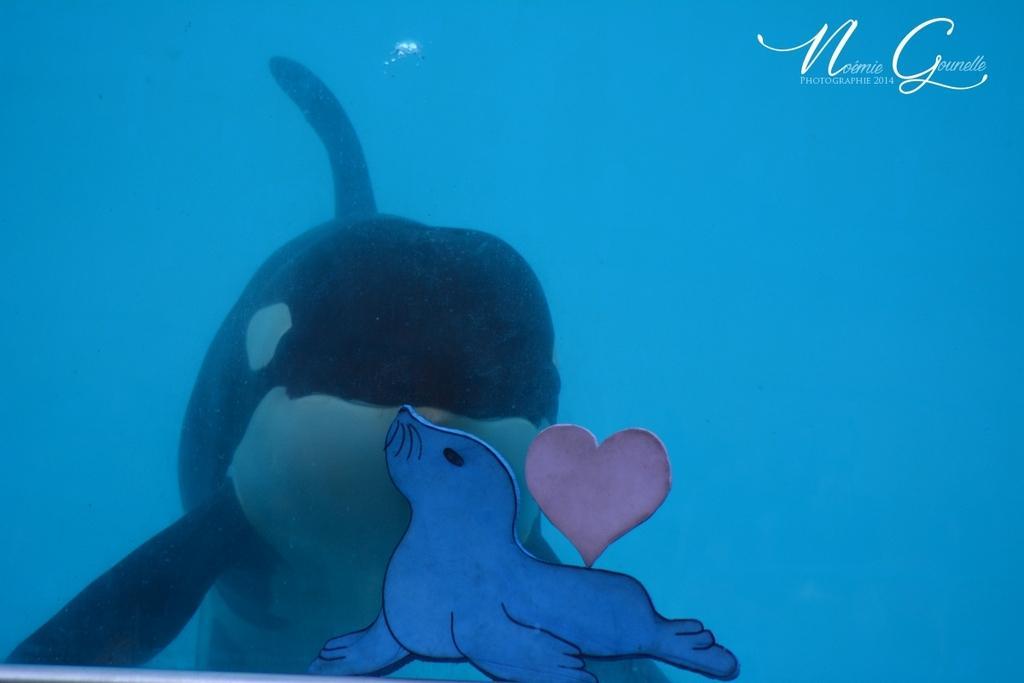Please provide a concise description of this image. In this image I can see the dolphin in the water. I can see the water in blue color. I can also see the toy which is made up of paper. 